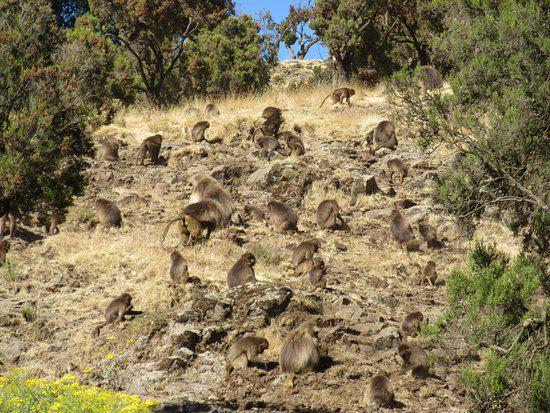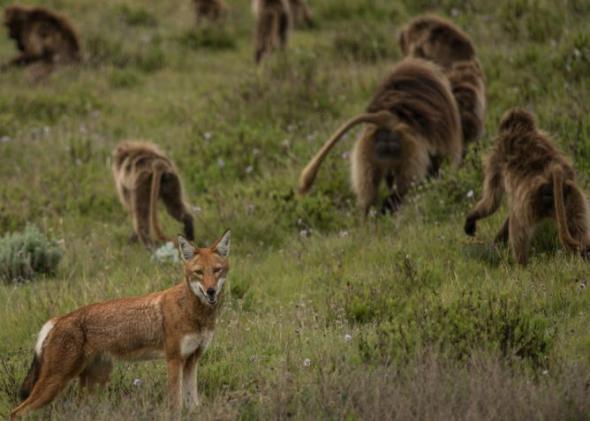The first image is the image on the left, the second image is the image on the right. Analyze the images presented: Is the assertion "A red fox-like animal is standing in a scene near some monkeys." valid? Answer yes or no. Yes. 